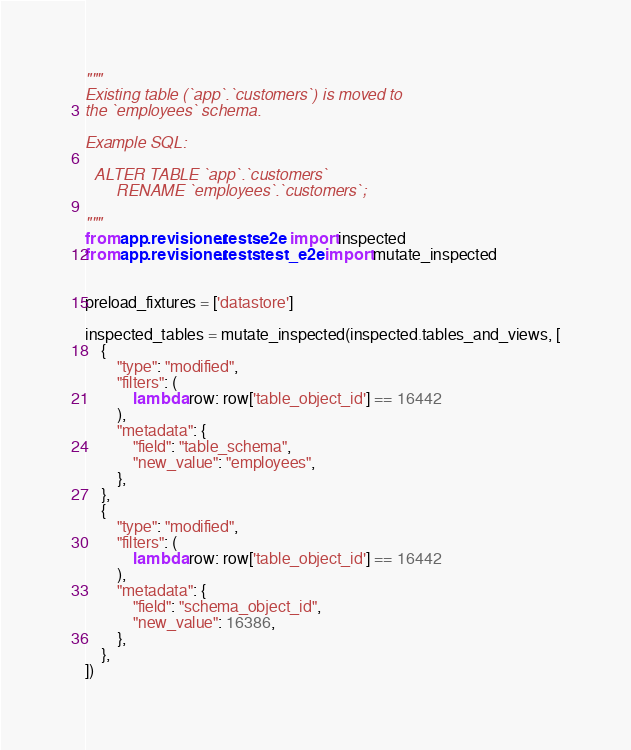<code> <loc_0><loc_0><loc_500><loc_500><_Python_>"""
Existing table (`app`.`customers`) is moved to
the `employees` schema.

Example SQL:

  ALTER TABLE `app`.`customers`
       RENAME `employees`.`customers`;

"""
from app.revisioner.tests.e2e import inspected
from app.revisioner.tests.test_e2e import mutate_inspected


preload_fixtures = ['datastore']

inspected_tables = mutate_inspected(inspected.tables_and_views, [
    {
        "type": "modified",
        "filters": (
            lambda row: row['table_object_id'] == 16442
        ),
        "metadata": {
            "field": "table_schema",
            "new_value": "employees",
        },
    },
    {
        "type": "modified",
        "filters": (
            lambda row: row['table_object_id'] == 16442
        ),
        "metadata": {
            "field": "schema_object_id",
            "new_value": 16386,
        },
    },
])
</code> 